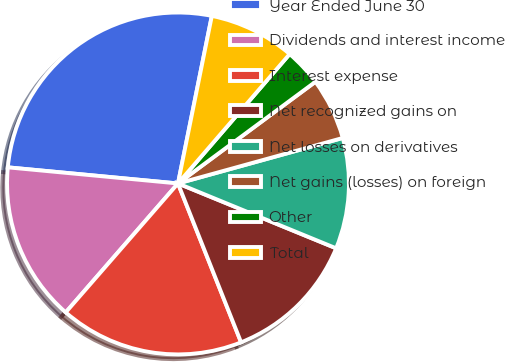Convert chart. <chart><loc_0><loc_0><loc_500><loc_500><pie_chart><fcel>Year Ended June 30<fcel>Dividends and interest income<fcel>Interest expense<fcel>Net recognized gains on<fcel>Net losses on derivatives<fcel>Net gains (losses) on foreign<fcel>Other<fcel>Total<nl><fcel>26.67%<fcel>15.1%<fcel>17.42%<fcel>12.79%<fcel>10.48%<fcel>5.85%<fcel>3.53%<fcel>8.16%<nl></chart> 